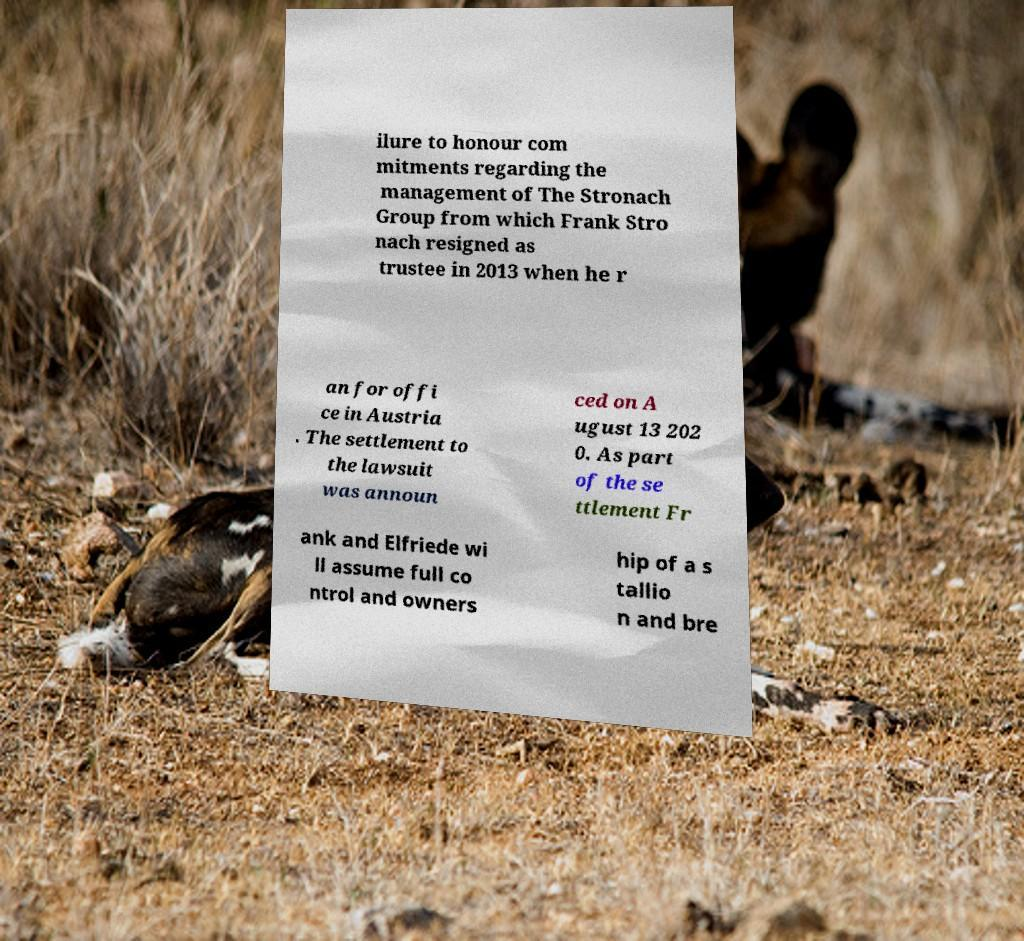Please read and relay the text visible in this image. What does it say? ilure to honour com mitments regarding the management of The Stronach Group from which Frank Stro nach resigned as trustee in 2013 when he r an for offi ce in Austria . The settlement to the lawsuit was announ ced on A ugust 13 202 0. As part of the se ttlement Fr ank and Elfriede wi ll assume full co ntrol and owners hip of a s tallio n and bre 